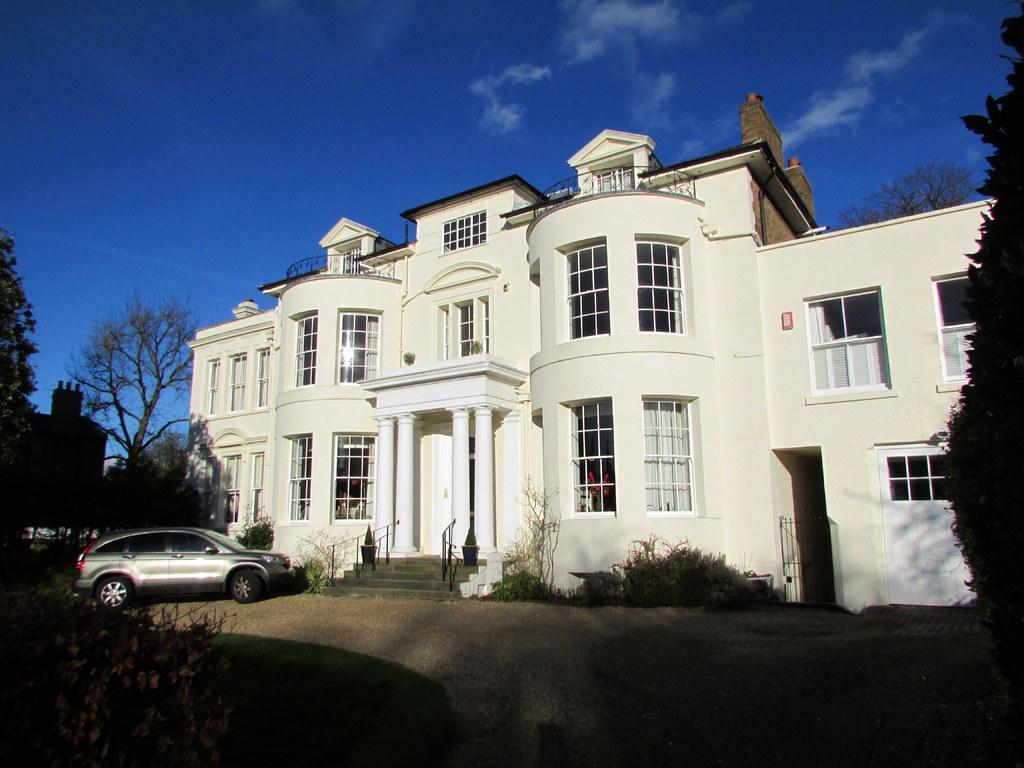Describe this image in one or two sentences. In this image we can see a building and there is a car in front of the building. We can see some trees and plants and at the top we can see the sky. 